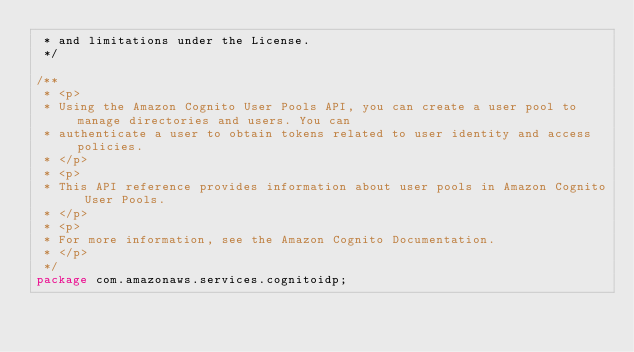<code> <loc_0><loc_0><loc_500><loc_500><_Java_> * and limitations under the License.
 */

/**
 * <p>
 * Using the Amazon Cognito User Pools API, you can create a user pool to manage directories and users. You can
 * authenticate a user to obtain tokens related to user identity and access policies.
 * </p>
 * <p>
 * This API reference provides information about user pools in Amazon Cognito User Pools.
 * </p>
 * <p>
 * For more information, see the Amazon Cognito Documentation.
 * </p>
 */
package com.amazonaws.services.cognitoidp;

</code> 